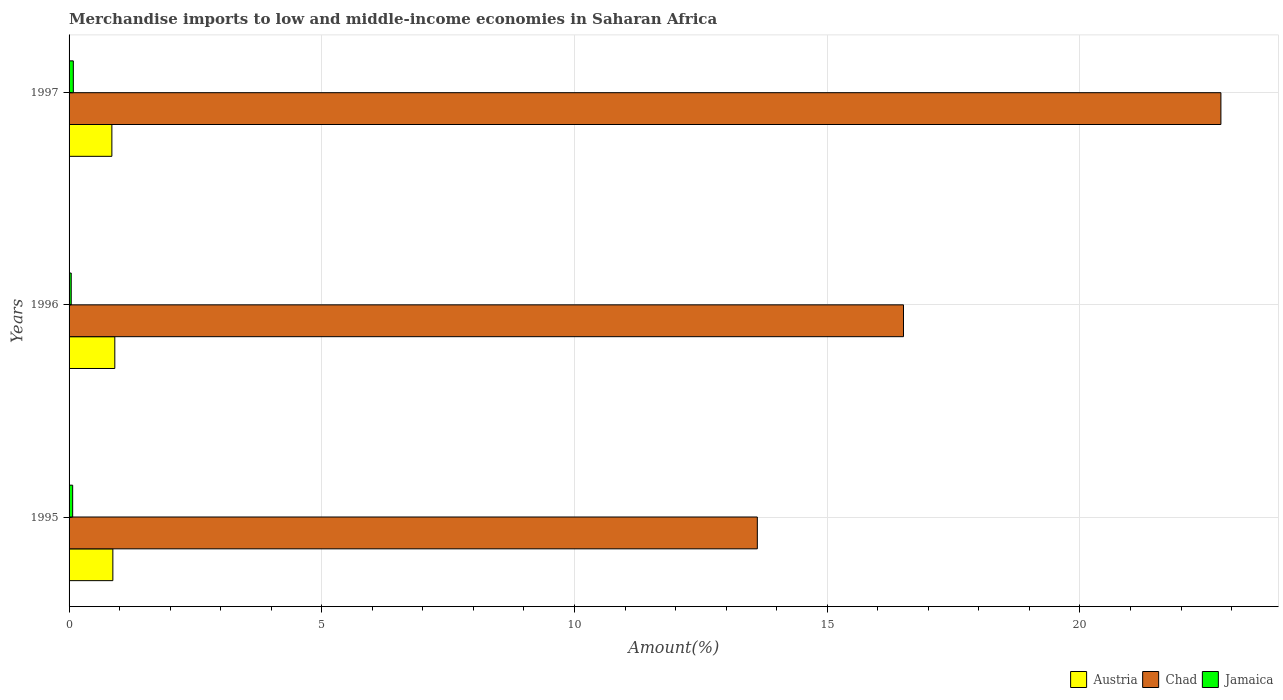Are the number of bars per tick equal to the number of legend labels?
Your answer should be very brief. Yes. What is the label of the 3rd group of bars from the top?
Give a very brief answer. 1995. What is the percentage of amount earned from merchandise imports in Jamaica in 1996?
Make the answer very short. 0.04. Across all years, what is the maximum percentage of amount earned from merchandise imports in Chad?
Keep it short and to the point. 22.79. Across all years, what is the minimum percentage of amount earned from merchandise imports in Jamaica?
Offer a terse response. 0.04. In which year was the percentage of amount earned from merchandise imports in Austria maximum?
Your answer should be very brief. 1996. In which year was the percentage of amount earned from merchandise imports in Austria minimum?
Make the answer very short. 1997. What is the total percentage of amount earned from merchandise imports in Austria in the graph?
Make the answer very short. 2.62. What is the difference between the percentage of amount earned from merchandise imports in Austria in 1995 and that in 1996?
Ensure brevity in your answer.  -0.04. What is the difference between the percentage of amount earned from merchandise imports in Austria in 1995 and the percentage of amount earned from merchandise imports in Chad in 1997?
Give a very brief answer. -21.92. What is the average percentage of amount earned from merchandise imports in Jamaica per year?
Keep it short and to the point. 0.07. In the year 1997, what is the difference between the percentage of amount earned from merchandise imports in Chad and percentage of amount earned from merchandise imports in Jamaica?
Offer a very short reply. 22.7. What is the ratio of the percentage of amount earned from merchandise imports in Chad in 1996 to that in 1997?
Offer a very short reply. 0.72. What is the difference between the highest and the second highest percentage of amount earned from merchandise imports in Austria?
Your response must be concise. 0.04. What is the difference between the highest and the lowest percentage of amount earned from merchandise imports in Austria?
Provide a succinct answer. 0.06. In how many years, is the percentage of amount earned from merchandise imports in Jamaica greater than the average percentage of amount earned from merchandise imports in Jamaica taken over all years?
Ensure brevity in your answer.  2. What does the 2nd bar from the top in 1996 represents?
Give a very brief answer. Chad. What is the difference between two consecutive major ticks on the X-axis?
Your answer should be very brief. 5. Does the graph contain any zero values?
Give a very brief answer. No. Does the graph contain grids?
Your answer should be very brief. Yes. Where does the legend appear in the graph?
Offer a very short reply. Bottom right. How are the legend labels stacked?
Your answer should be very brief. Horizontal. What is the title of the graph?
Give a very brief answer. Merchandise imports to low and middle-income economies in Saharan Africa. What is the label or title of the X-axis?
Your response must be concise. Amount(%). What is the Amount(%) of Austria in 1995?
Keep it short and to the point. 0.87. What is the Amount(%) of Chad in 1995?
Your answer should be very brief. 13.62. What is the Amount(%) of Jamaica in 1995?
Your answer should be compact. 0.07. What is the Amount(%) of Austria in 1996?
Provide a succinct answer. 0.91. What is the Amount(%) of Chad in 1996?
Make the answer very short. 16.51. What is the Amount(%) in Jamaica in 1996?
Your response must be concise. 0.04. What is the Amount(%) in Austria in 1997?
Provide a short and direct response. 0.85. What is the Amount(%) in Chad in 1997?
Your answer should be compact. 22.79. What is the Amount(%) of Jamaica in 1997?
Give a very brief answer. 0.08. Across all years, what is the maximum Amount(%) of Austria?
Provide a short and direct response. 0.91. Across all years, what is the maximum Amount(%) in Chad?
Keep it short and to the point. 22.79. Across all years, what is the maximum Amount(%) of Jamaica?
Offer a very short reply. 0.08. Across all years, what is the minimum Amount(%) of Austria?
Your answer should be very brief. 0.85. Across all years, what is the minimum Amount(%) of Chad?
Give a very brief answer. 13.62. Across all years, what is the minimum Amount(%) of Jamaica?
Give a very brief answer. 0.04. What is the total Amount(%) in Austria in the graph?
Your response must be concise. 2.62. What is the total Amount(%) of Chad in the graph?
Keep it short and to the point. 52.91. What is the total Amount(%) in Jamaica in the graph?
Give a very brief answer. 0.2. What is the difference between the Amount(%) in Austria in 1995 and that in 1996?
Give a very brief answer. -0.04. What is the difference between the Amount(%) in Chad in 1995 and that in 1996?
Offer a terse response. -2.89. What is the difference between the Amount(%) in Jamaica in 1995 and that in 1996?
Offer a terse response. 0.03. What is the difference between the Amount(%) in Austria in 1995 and that in 1997?
Your answer should be very brief. 0.02. What is the difference between the Amount(%) of Chad in 1995 and that in 1997?
Your response must be concise. -9.17. What is the difference between the Amount(%) in Jamaica in 1995 and that in 1997?
Offer a terse response. -0.01. What is the difference between the Amount(%) in Austria in 1996 and that in 1997?
Offer a terse response. 0.06. What is the difference between the Amount(%) in Chad in 1996 and that in 1997?
Your answer should be compact. -6.28. What is the difference between the Amount(%) in Jamaica in 1996 and that in 1997?
Offer a very short reply. -0.04. What is the difference between the Amount(%) in Austria in 1995 and the Amount(%) in Chad in 1996?
Offer a terse response. -15.64. What is the difference between the Amount(%) of Austria in 1995 and the Amount(%) of Jamaica in 1996?
Provide a short and direct response. 0.82. What is the difference between the Amount(%) in Chad in 1995 and the Amount(%) in Jamaica in 1996?
Offer a very short reply. 13.57. What is the difference between the Amount(%) of Austria in 1995 and the Amount(%) of Chad in 1997?
Keep it short and to the point. -21.92. What is the difference between the Amount(%) of Austria in 1995 and the Amount(%) of Jamaica in 1997?
Provide a succinct answer. 0.78. What is the difference between the Amount(%) of Chad in 1995 and the Amount(%) of Jamaica in 1997?
Provide a succinct answer. 13.53. What is the difference between the Amount(%) in Austria in 1996 and the Amount(%) in Chad in 1997?
Offer a terse response. -21.88. What is the difference between the Amount(%) in Austria in 1996 and the Amount(%) in Jamaica in 1997?
Provide a short and direct response. 0.82. What is the difference between the Amount(%) in Chad in 1996 and the Amount(%) in Jamaica in 1997?
Keep it short and to the point. 16.42. What is the average Amount(%) of Austria per year?
Your response must be concise. 0.87. What is the average Amount(%) in Chad per year?
Keep it short and to the point. 17.64. What is the average Amount(%) of Jamaica per year?
Provide a short and direct response. 0.07. In the year 1995, what is the difference between the Amount(%) of Austria and Amount(%) of Chad?
Your response must be concise. -12.75. In the year 1995, what is the difference between the Amount(%) in Austria and Amount(%) in Jamaica?
Your answer should be compact. 0.8. In the year 1995, what is the difference between the Amount(%) of Chad and Amount(%) of Jamaica?
Offer a very short reply. 13.55. In the year 1996, what is the difference between the Amount(%) of Austria and Amount(%) of Chad?
Provide a short and direct response. -15.6. In the year 1996, what is the difference between the Amount(%) in Austria and Amount(%) in Jamaica?
Provide a succinct answer. 0.86. In the year 1996, what is the difference between the Amount(%) of Chad and Amount(%) of Jamaica?
Make the answer very short. 16.47. In the year 1997, what is the difference between the Amount(%) in Austria and Amount(%) in Chad?
Provide a succinct answer. -21.94. In the year 1997, what is the difference between the Amount(%) in Austria and Amount(%) in Jamaica?
Ensure brevity in your answer.  0.76. In the year 1997, what is the difference between the Amount(%) in Chad and Amount(%) in Jamaica?
Your response must be concise. 22.7. What is the ratio of the Amount(%) of Austria in 1995 to that in 1996?
Provide a short and direct response. 0.96. What is the ratio of the Amount(%) in Chad in 1995 to that in 1996?
Your answer should be very brief. 0.82. What is the ratio of the Amount(%) in Jamaica in 1995 to that in 1996?
Provide a short and direct response. 1.68. What is the ratio of the Amount(%) of Austria in 1995 to that in 1997?
Provide a succinct answer. 1.02. What is the ratio of the Amount(%) of Chad in 1995 to that in 1997?
Provide a succinct answer. 0.6. What is the ratio of the Amount(%) in Jamaica in 1995 to that in 1997?
Your answer should be very brief. 0.85. What is the ratio of the Amount(%) in Austria in 1996 to that in 1997?
Offer a terse response. 1.07. What is the ratio of the Amount(%) of Chad in 1996 to that in 1997?
Keep it short and to the point. 0.72. What is the ratio of the Amount(%) of Jamaica in 1996 to that in 1997?
Make the answer very short. 0.5. What is the difference between the highest and the second highest Amount(%) in Austria?
Offer a terse response. 0.04. What is the difference between the highest and the second highest Amount(%) of Chad?
Make the answer very short. 6.28. What is the difference between the highest and the second highest Amount(%) in Jamaica?
Give a very brief answer. 0.01. What is the difference between the highest and the lowest Amount(%) in Austria?
Provide a short and direct response. 0.06. What is the difference between the highest and the lowest Amount(%) in Chad?
Provide a succinct answer. 9.17. What is the difference between the highest and the lowest Amount(%) of Jamaica?
Keep it short and to the point. 0.04. 